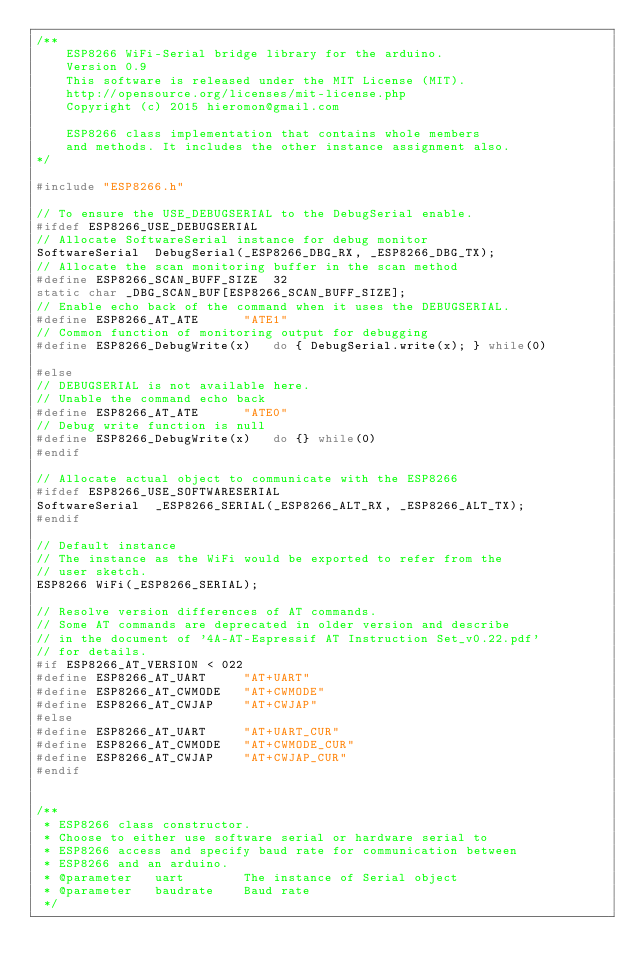Convert code to text. <code><loc_0><loc_0><loc_500><loc_500><_C++_>/**
	ESP8266 WiFi-Serial bridge library for the arduino.
	Version 0.9
	This software is released under the MIT License (MIT).
	http://opensource.org/licenses/mit-license.php
	Copyright (c) 2015 hieromon@gmail.com
  
	ESP8266 class implementation that contains whole members
	and methods. It includes the other instance assignment also.
*/

#include "ESP8266.h"

// To ensure the USE_DEBUGSERIAL to the DebugSerial enable.
#ifdef ESP8266_USE_DEBUGSERIAL
// Allocate SoftwareSerial instance for debug monitor
SoftwareSerial	DebugSerial(_ESP8266_DBG_RX, _ESP8266_DBG_TX);
// Allocate the scan monitoring buffer in the scan method
#define ESP8266_SCAN_BUFF_SIZE	32
static char	_DBG_SCAN_BUF[ESP8266_SCAN_BUFF_SIZE];
// Enable echo back of the command when it uses the DEBUGSERIAL.
#define ESP8266_AT_ATE		"ATE1"
// Common function of monitoring output for debugging
#define ESP8266_DebugWrite(x)	do { DebugSerial.write(x); } while(0)

#else
// DEBUGSERIAL is not available here.
// Unable the command echo back
#define ESP8266_AT_ATE		"ATE0"
// Debug write function is null
#define ESP8266_DebugWrite(x)	do {} while(0)
#endif

// Allocate actual object to communicate with the ESP8266
#ifdef ESP8266_USE_SOFTWARESERIAL
SoftwareSerial	_ESP8266_SERIAL(_ESP8266_ALT_RX, _ESP8266_ALT_TX);
#endif

// Default instance
// The instance as the WiFi would be exported to refer from the
// user sketch.
ESP8266	WiFi(_ESP8266_SERIAL);

// Resolve version differences of AT commands.
// Some AT commands are deprecated in older version and describe
// in the document of '4A-AT-Espressif AT Instruction Set_v0.22.pdf'
// for details.
#if ESP8266_AT_VERSION < 022
#define ESP8266_AT_UART		"AT+UART"
#define ESP8266_AT_CWMODE	"AT+CWMODE"
#define ESP8266_AT_CWJAP	"AT+CWJAP"
#else
#define ESP8266_AT_UART		"AT+UART_CUR"
#define ESP8266_AT_CWMODE	"AT+CWMODE_CUR"
#define ESP8266_AT_CWJAP	"AT+CWJAP_CUR"
#endif


/**
 * ESP8266 class constructor.
 * Choose to either use software serial or hardware serial to
 * ESP8266 access and specify baud rate for communication between
 * ESP8266 and an arduino.
 * @parameter	uart		The instance of Serial object
 * @parameter	baudrate	Baud rate
 */</code> 